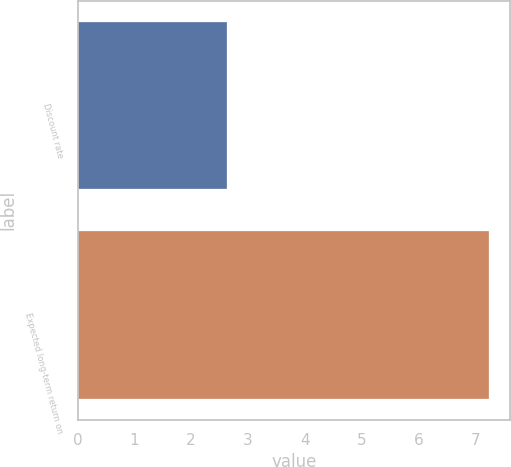Convert chart. <chart><loc_0><loc_0><loc_500><loc_500><bar_chart><fcel>Discount rate<fcel>Expected long-term return on<nl><fcel>2.63<fcel>7.25<nl></chart> 